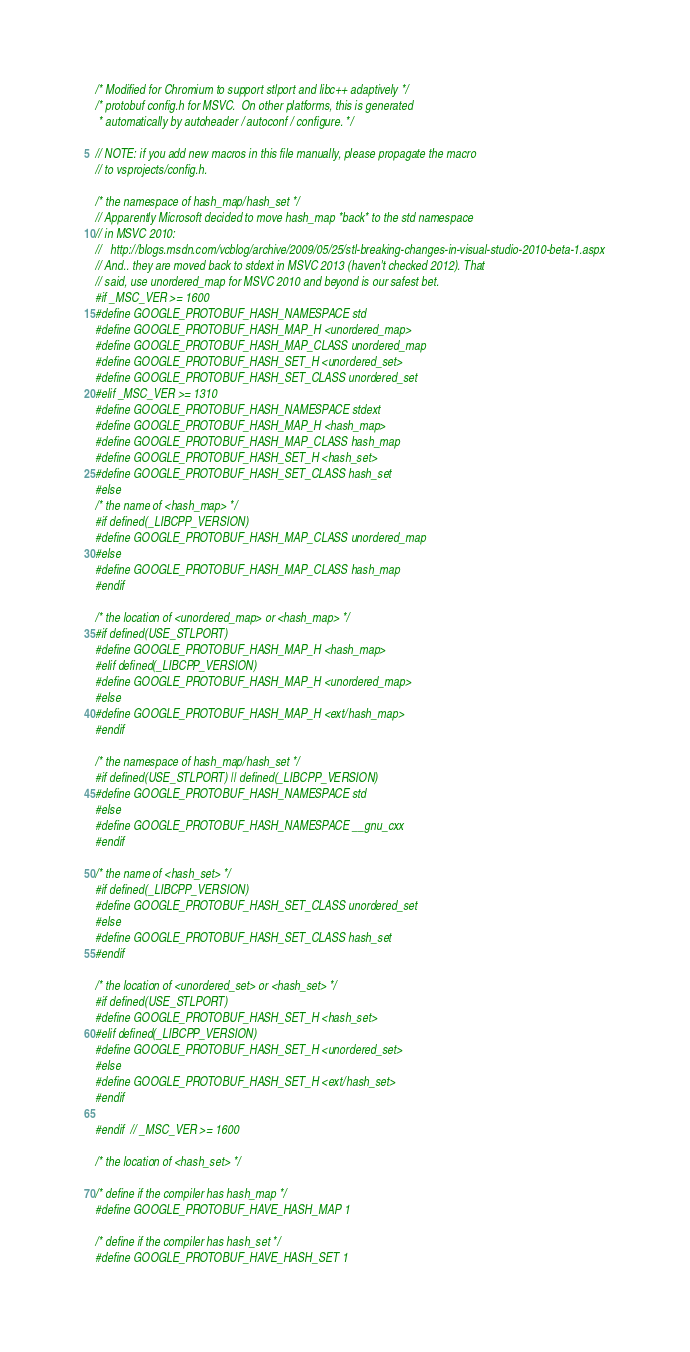Convert code to text. <code><loc_0><loc_0><loc_500><loc_500><_C_>/* Modified for Chromium to support stlport and libc++ adaptively */
/* protobuf config.h for MSVC.  On other platforms, this is generated
 * automatically by autoheader / autoconf / configure. */

// NOTE: if you add new macros in this file manually, please propagate the macro
// to vsprojects/config.h.

/* the namespace of hash_map/hash_set */
// Apparently Microsoft decided to move hash_map *back* to the std namespace
// in MSVC 2010:
//   http://blogs.msdn.com/vcblog/archive/2009/05/25/stl-breaking-changes-in-visual-studio-2010-beta-1.aspx
// And.. they are moved back to stdext in MSVC 2013 (haven't checked 2012). That
// said, use unordered_map for MSVC 2010 and beyond is our safest bet.
#if _MSC_VER >= 1600
#define GOOGLE_PROTOBUF_HASH_NAMESPACE std
#define GOOGLE_PROTOBUF_HASH_MAP_H <unordered_map>
#define GOOGLE_PROTOBUF_HASH_MAP_CLASS unordered_map
#define GOOGLE_PROTOBUF_HASH_SET_H <unordered_set>
#define GOOGLE_PROTOBUF_HASH_SET_CLASS unordered_set
#elif _MSC_VER >= 1310
#define GOOGLE_PROTOBUF_HASH_NAMESPACE stdext
#define GOOGLE_PROTOBUF_HASH_MAP_H <hash_map>
#define GOOGLE_PROTOBUF_HASH_MAP_CLASS hash_map
#define GOOGLE_PROTOBUF_HASH_SET_H <hash_set>
#define GOOGLE_PROTOBUF_HASH_SET_CLASS hash_set
#else
/* the name of <hash_map> */
#if defined(_LIBCPP_VERSION)
#define GOOGLE_PROTOBUF_HASH_MAP_CLASS unordered_map
#else
#define GOOGLE_PROTOBUF_HASH_MAP_CLASS hash_map
#endif

/* the location of <unordered_map> or <hash_map> */
#if defined(USE_STLPORT)
#define GOOGLE_PROTOBUF_HASH_MAP_H <hash_map>
#elif defined(_LIBCPP_VERSION)
#define GOOGLE_PROTOBUF_HASH_MAP_H <unordered_map>
#else
#define GOOGLE_PROTOBUF_HASH_MAP_H <ext/hash_map>
#endif

/* the namespace of hash_map/hash_set */
#if defined(USE_STLPORT) || defined(_LIBCPP_VERSION)
#define GOOGLE_PROTOBUF_HASH_NAMESPACE std
#else
#define GOOGLE_PROTOBUF_HASH_NAMESPACE __gnu_cxx
#endif

/* the name of <hash_set> */
#if defined(_LIBCPP_VERSION)
#define GOOGLE_PROTOBUF_HASH_SET_CLASS unordered_set
#else
#define GOOGLE_PROTOBUF_HASH_SET_CLASS hash_set
#endif

/* the location of <unordered_set> or <hash_set> */
#if defined(USE_STLPORT)
#define GOOGLE_PROTOBUF_HASH_SET_H <hash_set>
#elif defined(_LIBCPP_VERSION)
#define GOOGLE_PROTOBUF_HASH_SET_H <unordered_set>
#else
#define GOOGLE_PROTOBUF_HASH_SET_H <ext/hash_set>
#endif

#endif  // _MSC_VER >= 1600

/* the location of <hash_set> */

/* define if the compiler has hash_map */
#define GOOGLE_PROTOBUF_HAVE_HASH_MAP 1

/* define if the compiler has hash_set */
#define GOOGLE_PROTOBUF_HAVE_HASH_SET 1
</code> 